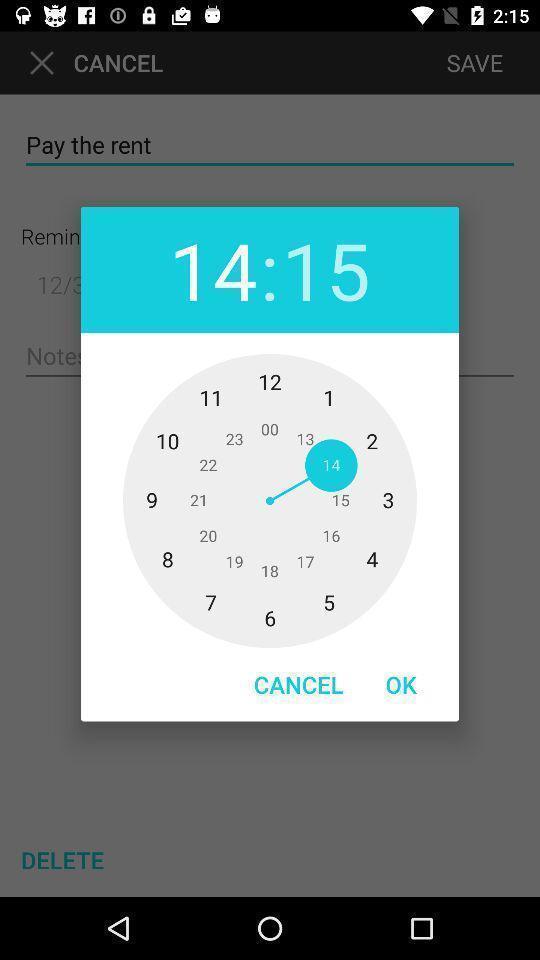Summarize the information in this screenshot. Popup showing about to set time. 